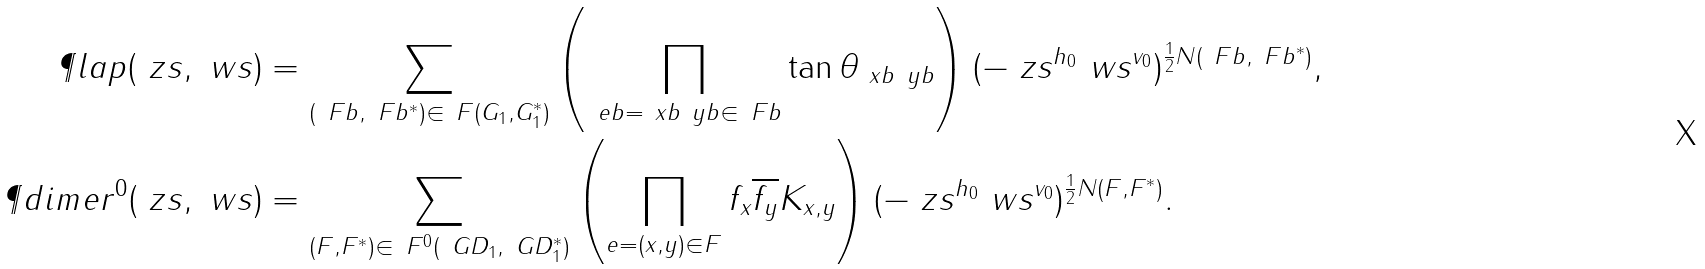Convert formula to latex. <formula><loc_0><loc_0><loc_500><loc_500>\P l a p ( \ z s , \ w s ) & = \sum _ { ( \ F b , \ F b ^ { * } ) \in \ F ( G _ { 1 } , G _ { 1 } ^ { * } ) } \left ( \prod _ { \ e b = \ x b \ y b \in \ F b } \tan \theta _ { \ x b \ y b } \right ) ( - \ z s ^ { h _ { 0 } } \ w s ^ { v _ { 0 } } ) ^ { \frac { 1 } { 2 } N ( \ F b , \ F b ^ { * } ) } , \\ \P d i m e r ^ { 0 } ( \ z s , \ w s ) & = \sum _ { ( F , F ^ { * } ) \in \ F ^ { 0 } ( \ G D _ { 1 } , \ G D _ { 1 } ^ { * } ) } \left ( \prod _ { e = ( x , y ) \in F } f _ { x } \overline { f _ { y } } K _ { x , y } \right ) ( - \ z s ^ { h _ { 0 } } \ w s ^ { v _ { 0 } } ) ^ { \frac { 1 } { 2 } N ( F , F ^ { * } ) } .</formula> 